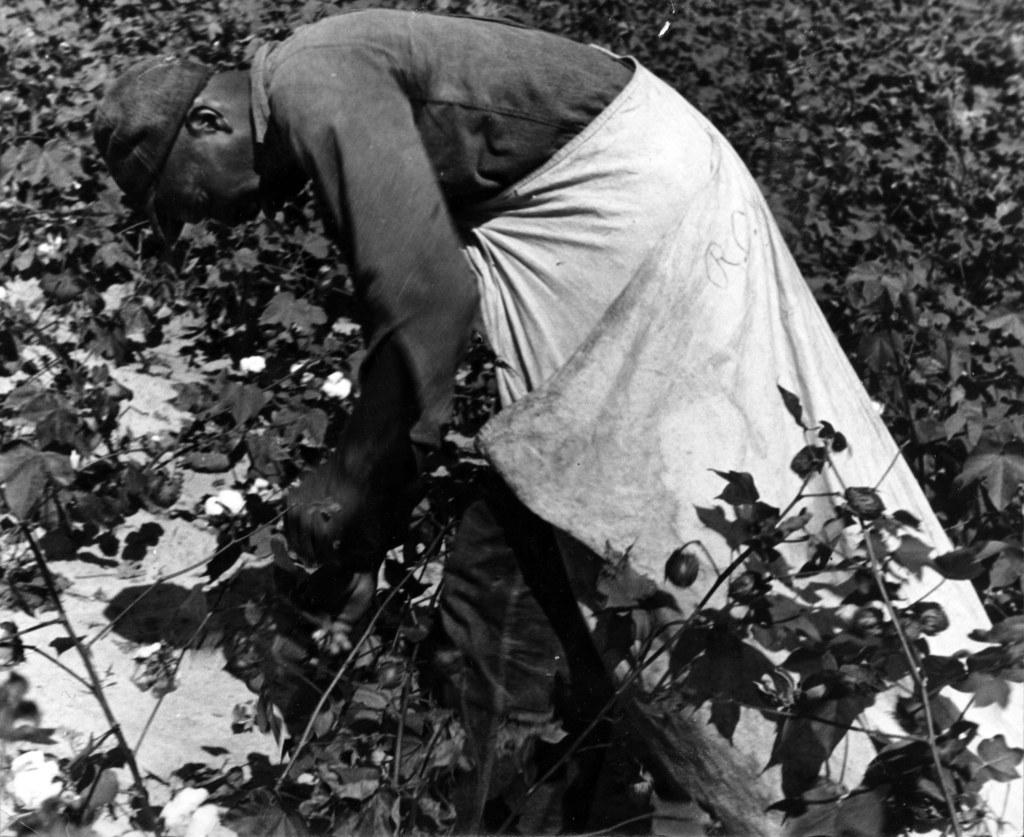How would you summarize this image in a sentence or two? It is a black and white image. In this image we can see the man wearing the cap. We can also see the plants. The man is wearing some white color cloth. 